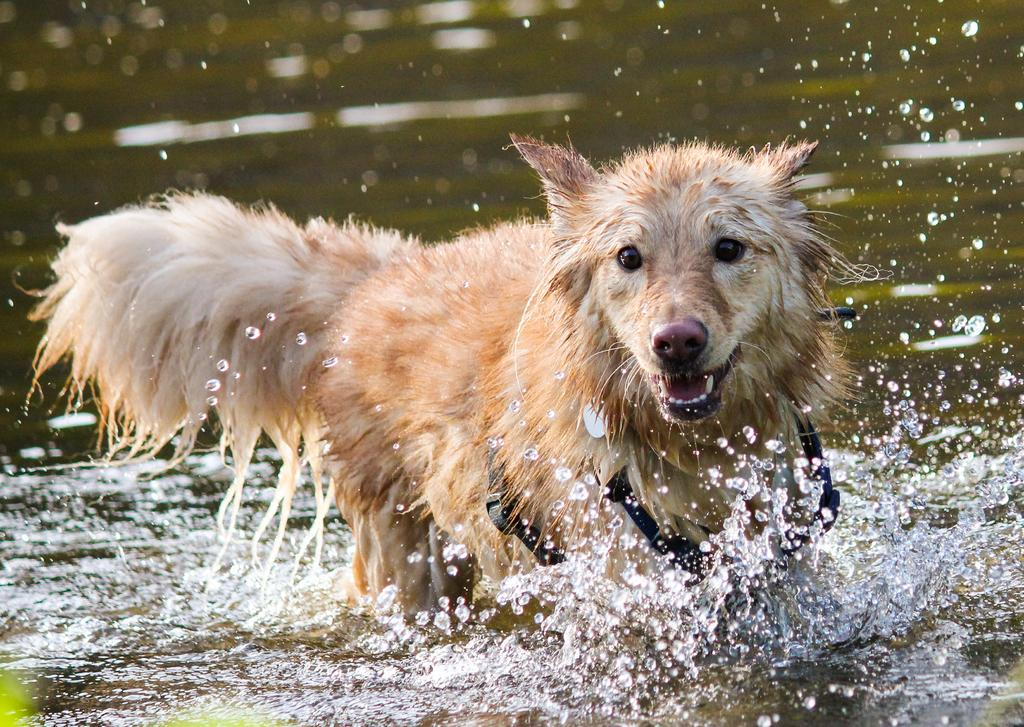What type of animal is in the image? There is an animal in the image, but the specific type cannot be determined from the provided facts. Where is the animal located in the image? The animal is in water. What type of chicken is sitting on the ladybug in the image? There is no chicken or ladybug present in the image. 